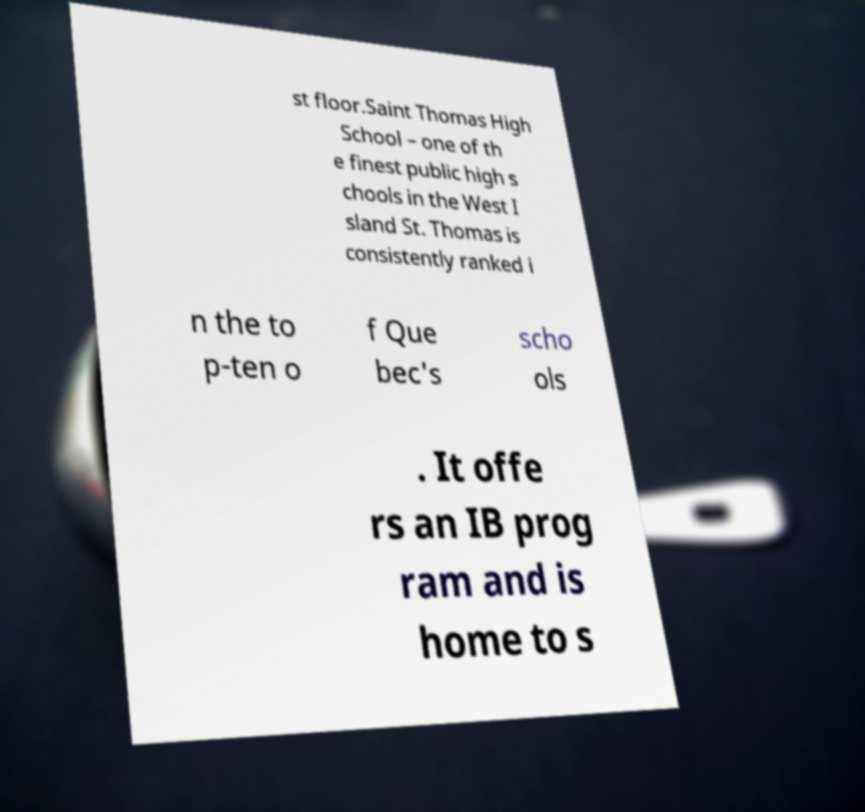What messages or text are displayed in this image? I need them in a readable, typed format. st floor.Saint Thomas High School – one of th e finest public high s chools in the West I sland St. Thomas is consistently ranked i n the to p-ten o f Que bec's scho ols . It offe rs an IB prog ram and is home to s 